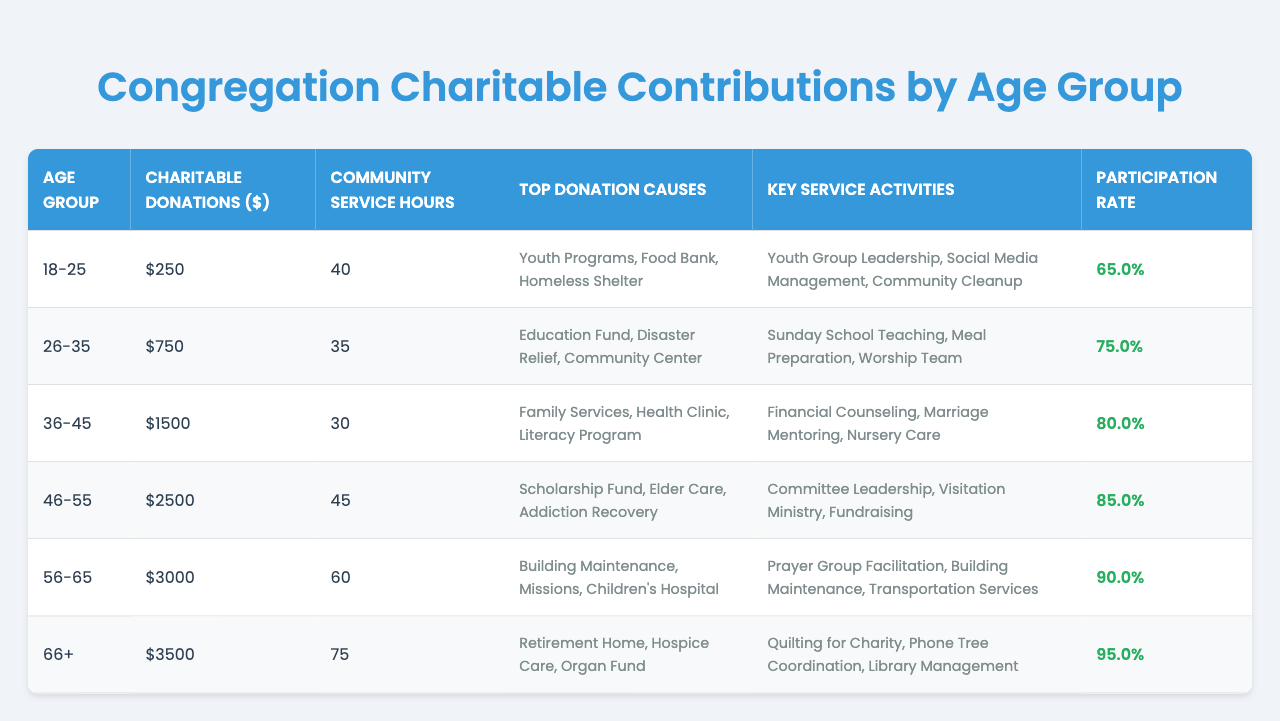What is the total amount of charitable donations made by the 36-45 age group? The table shows that the charitable donations for the 36-45 age group are $1500.
Answer: 1500 Which age group has the highest community service hours? According to the table, the 66+ age group has the highest community service hours with 75 hours.
Answer: 66+ What are the top donation causes for the 46-55 age group? The table lists the top donation causes for the 46-55 age group as Scholarship Fund, Elder Care, and Addiction Recovery.
Answer: Scholarship Fund, Elder Care, Addiction Recovery How many community service hours did those aged 18-25 contribute compared to those aged 56-65? The 18-25 age group contributed 40 hours, while the 56-65 group contributed 60 hours. The difference is 60 - 40 = 20 hours.
Answer: 20 hours What percentage of participation rate does the 26-35 age group have? The participation rate for the 26-35 age group is presented as 75% in the table.
Answer: 75% Which age group contributed the least in charitable donations? The 18-25 age group contributed the least in charitable donations, totaling $250.
Answer: 18-25 What is the difference in charitable donations between the 66+ age group and the 26-35 age group? The 66+ age group donated $3500 while the 26-35 age group donated $750. The difference is 3500 - 750 = 2750.
Answer: 2750 Which age group has the lowest participation rate? The participation rate is lowest for the 18-25 age group, which is 65%.
Answer: 18-25 If we average the community service hours of the 36-45 and 46-55 age groups, what is the result? The community service hours for the 36-45 age group is 30, and for the 46-55 group is 45. The average can be calculated as (30 + 45) / 2 = 37.5 hours.
Answer: 37.5 hours Are there any age groups that contributed more than $2500 in charitable donations? Yes, the 46-55, 56-65, and 66+ age groups contributed more than $2500 in charitable donations.
Answer: Yes If we consider only those who are 56 years or older, what is the total of charitable donations made by these age groups? The charitable donations for the 56-65 age group are $3000 and for the 66+ age group are $3500. The total is 3000 + 3500 = 6500.
Answer: 6500 